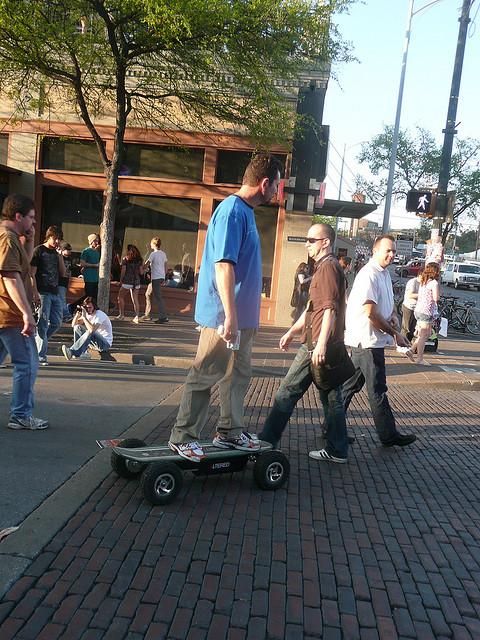Is this a normal skateboard?
Give a very brief answer. No. Is this an urban setting?
Keep it brief. Yes. Is it okay to walk at the crosswalk?
Quick response, please. Yes. 